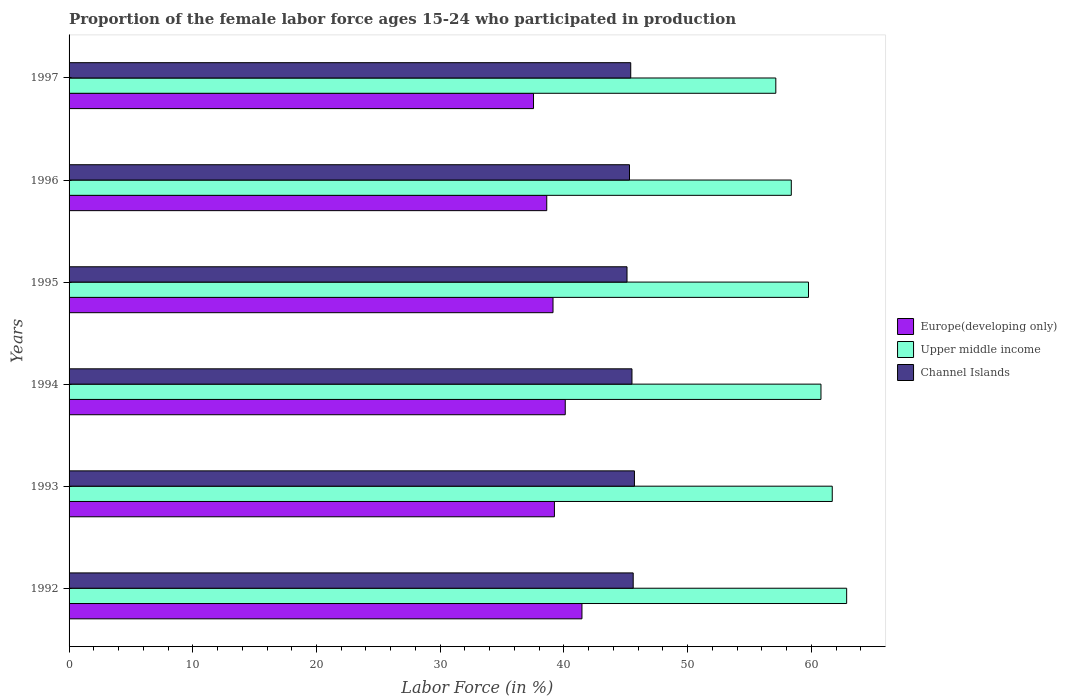How many different coloured bars are there?
Your response must be concise. 3. How many groups of bars are there?
Ensure brevity in your answer.  6. Are the number of bars per tick equal to the number of legend labels?
Offer a terse response. Yes. How many bars are there on the 2nd tick from the top?
Offer a terse response. 3. How many bars are there on the 6th tick from the bottom?
Your answer should be compact. 3. What is the proportion of the female labor force who participated in production in Europe(developing only) in 1997?
Give a very brief answer. 37.54. Across all years, what is the maximum proportion of the female labor force who participated in production in Upper middle income?
Your response must be concise. 62.85. Across all years, what is the minimum proportion of the female labor force who participated in production in Channel Islands?
Keep it short and to the point. 45.1. In which year was the proportion of the female labor force who participated in production in Upper middle income minimum?
Provide a succinct answer. 1997. What is the total proportion of the female labor force who participated in production in Europe(developing only) in the graph?
Make the answer very short. 236.07. What is the difference between the proportion of the female labor force who participated in production in Channel Islands in 1995 and that in 1997?
Your response must be concise. -0.3. What is the difference between the proportion of the female labor force who participated in production in Upper middle income in 1997 and the proportion of the female labor force who participated in production in Channel Islands in 1995?
Give a very brief answer. 12.03. What is the average proportion of the female labor force who participated in production in Europe(developing only) per year?
Your answer should be compact. 39.34. In the year 1994, what is the difference between the proportion of the female labor force who participated in production in Channel Islands and proportion of the female labor force who participated in production in Europe(developing only)?
Provide a short and direct response. 5.39. What is the ratio of the proportion of the female labor force who participated in production in Europe(developing only) in 1993 to that in 1997?
Provide a succinct answer. 1.05. Is the proportion of the female labor force who participated in production in Channel Islands in 1996 less than that in 1997?
Ensure brevity in your answer.  Yes. What is the difference between the highest and the second highest proportion of the female labor force who participated in production in Upper middle income?
Provide a short and direct response. 1.16. What is the difference between the highest and the lowest proportion of the female labor force who participated in production in Upper middle income?
Offer a terse response. 5.73. Is the sum of the proportion of the female labor force who participated in production in Upper middle income in 1993 and 1997 greater than the maximum proportion of the female labor force who participated in production in Europe(developing only) across all years?
Give a very brief answer. Yes. What does the 2nd bar from the top in 1997 represents?
Give a very brief answer. Upper middle income. What does the 1st bar from the bottom in 1995 represents?
Your answer should be compact. Europe(developing only). Is it the case that in every year, the sum of the proportion of the female labor force who participated in production in Upper middle income and proportion of the female labor force who participated in production in Channel Islands is greater than the proportion of the female labor force who participated in production in Europe(developing only)?
Offer a terse response. Yes. How many bars are there?
Give a very brief answer. 18. Are all the bars in the graph horizontal?
Keep it short and to the point. Yes. What is the difference between two consecutive major ticks on the X-axis?
Offer a terse response. 10. Does the graph contain any zero values?
Provide a short and direct response. No. How are the legend labels stacked?
Keep it short and to the point. Vertical. What is the title of the graph?
Give a very brief answer. Proportion of the female labor force ages 15-24 who participated in production. Does "Belize" appear as one of the legend labels in the graph?
Offer a very short reply. No. What is the label or title of the X-axis?
Offer a terse response. Labor Force (in %). What is the Labor Force (in %) in Europe(developing only) in 1992?
Provide a short and direct response. 41.46. What is the Labor Force (in %) of Upper middle income in 1992?
Offer a terse response. 62.85. What is the Labor Force (in %) of Channel Islands in 1992?
Offer a terse response. 45.6. What is the Labor Force (in %) of Europe(developing only) in 1993?
Keep it short and to the point. 39.23. What is the Labor Force (in %) of Upper middle income in 1993?
Provide a succinct answer. 61.69. What is the Labor Force (in %) of Channel Islands in 1993?
Keep it short and to the point. 45.7. What is the Labor Force (in %) of Europe(developing only) in 1994?
Provide a succinct answer. 40.11. What is the Labor Force (in %) of Upper middle income in 1994?
Your answer should be very brief. 60.78. What is the Labor Force (in %) in Channel Islands in 1994?
Your answer should be very brief. 45.5. What is the Labor Force (in %) of Europe(developing only) in 1995?
Offer a very short reply. 39.12. What is the Labor Force (in %) in Upper middle income in 1995?
Offer a very short reply. 59.77. What is the Labor Force (in %) of Channel Islands in 1995?
Keep it short and to the point. 45.1. What is the Labor Force (in %) of Europe(developing only) in 1996?
Offer a terse response. 38.61. What is the Labor Force (in %) of Upper middle income in 1996?
Offer a terse response. 58.38. What is the Labor Force (in %) in Channel Islands in 1996?
Your answer should be very brief. 45.3. What is the Labor Force (in %) of Europe(developing only) in 1997?
Provide a succinct answer. 37.54. What is the Labor Force (in %) of Upper middle income in 1997?
Make the answer very short. 57.13. What is the Labor Force (in %) in Channel Islands in 1997?
Ensure brevity in your answer.  45.4. Across all years, what is the maximum Labor Force (in %) of Europe(developing only)?
Your response must be concise. 41.46. Across all years, what is the maximum Labor Force (in %) in Upper middle income?
Offer a terse response. 62.85. Across all years, what is the maximum Labor Force (in %) in Channel Islands?
Offer a terse response. 45.7. Across all years, what is the minimum Labor Force (in %) in Europe(developing only)?
Offer a terse response. 37.54. Across all years, what is the minimum Labor Force (in %) in Upper middle income?
Make the answer very short. 57.13. Across all years, what is the minimum Labor Force (in %) of Channel Islands?
Provide a succinct answer. 45.1. What is the total Labor Force (in %) of Europe(developing only) in the graph?
Your answer should be very brief. 236.07. What is the total Labor Force (in %) of Upper middle income in the graph?
Your response must be concise. 360.6. What is the total Labor Force (in %) in Channel Islands in the graph?
Make the answer very short. 272.6. What is the difference between the Labor Force (in %) of Europe(developing only) in 1992 and that in 1993?
Ensure brevity in your answer.  2.23. What is the difference between the Labor Force (in %) in Upper middle income in 1992 and that in 1993?
Make the answer very short. 1.16. What is the difference between the Labor Force (in %) of Europe(developing only) in 1992 and that in 1994?
Offer a very short reply. 1.35. What is the difference between the Labor Force (in %) of Upper middle income in 1992 and that in 1994?
Give a very brief answer. 2.08. What is the difference between the Labor Force (in %) of Channel Islands in 1992 and that in 1994?
Your response must be concise. 0.1. What is the difference between the Labor Force (in %) in Europe(developing only) in 1992 and that in 1995?
Ensure brevity in your answer.  2.34. What is the difference between the Labor Force (in %) of Upper middle income in 1992 and that in 1995?
Your answer should be compact. 3.08. What is the difference between the Labor Force (in %) in Europe(developing only) in 1992 and that in 1996?
Keep it short and to the point. 2.85. What is the difference between the Labor Force (in %) of Upper middle income in 1992 and that in 1996?
Give a very brief answer. 4.47. What is the difference between the Labor Force (in %) in Europe(developing only) in 1992 and that in 1997?
Provide a short and direct response. 3.91. What is the difference between the Labor Force (in %) in Upper middle income in 1992 and that in 1997?
Provide a short and direct response. 5.73. What is the difference between the Labor Force (in %) of Channel Islands in 1992 and that in 1997?
Offer a terse response. 0.2. What is the difference between the Labor Force (in %) of Europe(developing only) in 1993 and that in 1994?
Offer a terse response. -0.87. What is the difference between the Labor Force (in %) of Upper middle income in 1993 and that in 1994?
Ensure brevity in your answer.  0.91. What is the difference between the Labor Force (in %) in Channel Islands in 1993 and that in 1994?
Provide a short and direct response. 0.2. What is the difference between the Labor Force (in %) of Europe(developing only) in 1993 and that in 1995?
Ensure brevity in your answer.  0.11. What is the difference between the Labor Force (in %) in Upper middle income in 1993 and that in 1995?
Provide a succinct answer. 1.92. What is the difference between the Labor Force (in %) of Europe(developing only) in 1993 and that in 1996?
Your response must be concise. 0.62. What is the difference between the Labor Force (in %) of Upper middle income in 1993 and that in 1996?
Provide a short and direct response. 3.31. What is the difference between the Labor Force (in %) in Europe(developing only) in 1993 and that in 1997?
Make the answer very short. 1.69. What is the difference between the Labor Force (in %) of Upper middle income in 1993 and that in 1997?
Provide a succinct answer. 4.56. What is the difference between the Labor Force (in %) of Channel Islands in 1993 and that in 1997?
Your response must be concise. 0.3. What is the difference between the Labor Force (in %) of Upper middle income in 1994 and that in 1995?
Your response must be concise. 1.01. What is the difference between the Labor Force (in %) of Channel Islands in 1994 and that in 1995?
Ensure brevity in your answer.  0.4. What is the difference between the Labor Force (in %) in Europe(developing only) in 1994 and that in 1996?
Offer a very short reply. 1.5. What is the difference between the Labor Force (in %) in Upper middle income in 1994 and that in 1996?
Your answer should be compact. 2.4. What is the difference between the Labor Force (in %) in Channel Islands in 1994 and that in 1996?
Keep it short and to the point. 0.2. What is the difference between the Labor Force (in %) in Europe(developing only) in 1994 and that in 1997?
Provide a succinct answer. 2.56. What is the difference between the Labor Force (in %) of Upper middle income in 1994 and that in 1997?
Offer a very short reply. 3.65. What is the difference between the Labor Force (in %) in Channel Islands in 1994 and that in 1997?
Your answer should be very brief. 0.1. What is the difference between the Labor Force (in %) of Europe(developing only) in 1995 and that in 1996?
Ensure brevity in your answer.  0.51. What is the difference between the Labor Force (in %) of Upper middle income in 1995 and that in 1996?
Keep it short and to the point. 1.39. What is the difference between the Labor Force (in %) in Europe(developing only) in 1995 and that in 1997?
Ensure brevity in your answer.  1.58. What is the difference between the Labor Force (in %) of Upper middle income in 1995 and that in 1997?
Provide a short and direct response. 2.64. What is the difference between the Labor Force (in %) of Europe(developing only) in 1996 and that in 1997?
Provide a short and direct response. 1.07. What is the difference between the Labor Force (in %) in Upper middle income in 1996 and that in 1997?
Your answer should be very brief. 1.25. What is the difference between the Labor Force (in %) of Europe(developing only) in 1992 and the Labor Force (in %) of Upper middle income in 1993?
Give a very brief answer. -20.23. What is the difference between the Labor Force (in %) of Europe(developing only) in 1992 and the Labor Force (in %) of Channel Islands in 1993?
Provide a succinct answer. -4.24. What is the difference between the Labor Force (in %) in Upper middle income in 1992 and the Labor Force (in %) in Channel Islands in 1993?
Give a very brief answer. 17.15. What is the difference between the Labor Force (in %) of Europe(developing only) in 1992 and the Labor Force (in %) of Upper middle income in 1994?
Provide a short and direct response. -19.32. What is the difference between the Labor Force (in %) of Europe(developing only) in 1992 and the Labor Force (in %) of Channel Islands in 1994?
Your response must be concise. -4.04. What is the difference between the Labor Force (in %) in Upper middle income in 1992 and the Labor Force (in %) in Channel Islands in 1994?
Make the answer very short. 17.35. What is the difference between the Labor Force (in %) of Europe(developing only) in 1992 and the Labor Force (in %) of Upper middle income in 1995?
Provide a short and direct response. -18.31. What is the difference between the Labor Force (in %) of Europe(developing only) in 1992 and the Labor Force (in %) of Channel Islands in 1995?
Offer a terse response. -3.64. What is the difference between the Labor Force (in %) of Upper middle income in 1992 and the Labor Force (in %) of Channel Islands in 1995?
Your response must be concise. 17.75. What is the difference between the Labor Force (in %) in Europe(developing only) in 1992 and the Labor Force (in %) in Upper middle income in 1996?
Make the answer very short. -16.92. What is the difference between the Labor Force (in %) of Europe(developing only) in 1992 and the Labor Force (in %) of Channel Islands in 1996?
Give a very brief answer. -3.84. What is the difference between the Labor Force (in %) in Upper middle income in 1992 and the Labor Force (in %) in Channel Islands in 1996?
Offer a very short reply. 17.55. What is the difference between the Labor Force (in %) of Europe(developing only) in 1992 and the Labor Force (in %) of Upper middle income in 1997?
Provide a short and direct response. -15.67. What is the difference between the Labor Force (in %) in Europe(developing only) in 1992 and the Labor Force (in %) in Channel Islands in 1997?
Your answer should be compact. -3.94. What is the difference between the Labor Force (in %) of Upper middle income in 1992 and the Labor Force (in %) of Channel Islands in 1997?
Offer a very short reply. 17.45. What is the difference between the Labor Force (in %) in Europe(developing only) in 1993 and the Labor Force (in %) in Upper middle income in 1994?
Keep it short and to the point. -21.54. What is the difference between the Labor Force (in %) of Europe(developing only) in 1993 and the Labor Force (in %) of Channel Islands in 1994?
Provide a short and direct response. -6.27. What is the difference between the Labor Force (in %) in Upper middle income in 1993 and the Labor Force (in %) in Channel Islands in 1994?
Provide a succinct answer. 16.19. What is the difference between the Labor Force (in %) in Europe(developing only) in 1993 and the Labor Force (in %) in Upper middle income in 1995?
Provide a short and direct response. -20.54. What is the difference between the Labor Force (in %) in Europe(developing only) in 1993 and the Labor Force (in %) in Channel Islands in 1995?
Provide a short and direct response. -5.87. What is the difference between the Labor Force (in %) of Upper middle income in 1993 and the Labor Force (in %) of Channel Islands in 1995?
Keep it short and to the point. 16.59. What is the difference between the Labor Force (in %) in Europe(developing only) in 1993 and the Labor Force (in %) in Upper middle income in 1996?
Your response must be concise. -19.15. What is the difference between the Labor Force (in %) of Europe(developing only) in 1993 and the Labor Force (in %) of Channel Islands in 1996?
Offer a very short reply. -6.07. What is the difference between the Labor Force (in %) in Upper middle income in 1993 and the Labor Force (in %) in Channel Islands in 1996?
Your answer should be compact. 16.39. What is the difference between the Labor Force (in %) in Europe(developing only) in 1993 and the Labor Force (in %) in Upper middle income in 1997?
Provide a short and direct response. -17.9. What is the difference between the Labor Force (in %) of Europe(developing only) in 1993 and the Labor Force (in %) of Channel Islands in 1997?
Make the answer very short. -6.17. What is the difference between the Labor Force (in %) of Upper middle income in 1993 and the Labor Force (in %) of Channel Islands in 1997?
Make the answer very short. 16.29. What is the difference between the Labor Force (in %) in Europe(developing only) in 1994 and the Labor Force (in %) in Upper middle income in 1995?
Ensure brevity in your answer.  -19.66. What is the difference between the Labor Force (in %) in Europe(developing only) in 1994 and the Labor Force (in %) in Channel Islands in 1995?
Provide a short and direct response. -4.99. What is the difference between the Labor Force (in %) of Upper middle income in 1994 and the Labor Force (in %) of Channel Islands in 1995?
Offer a very short reply. 15.68. What is the difference between the Labor Force (in %) of Europe(developing only) in 1994 and the Labor Force (in %) of Upper middle income in 1996?
Ensure brevity in your answer.  -18.27. What is the difference between the Labor Force (in %) in Europe(developing only) in 1994 and the Labor Force (in %) in Channel Islands in 1996?
Your answer should be compact. -5.19. What is the difference between the Labor Force (in %) in Upper middle income in 1994 and the Labor Force (in %) in Channel Islands in 1996?
Ensure brevity in your answer.  15.48. What is the difference between the Labor Force (in %) of Europe(developing only) in 1994 and the Labor Force (in %) of Upper middle income in 1997?
Your response must be concise. -17.02. What is the difference between the Labor Force (in %) of Europe(developing only) in 1994 and the Labor Force (in %) of Channel Islands in 1997?
Provide a succinct answer. -5.29. What is the difference between the Labor Force (in %) in Upper middle income in 1994 and the Labor Force (in %) in Channel Islands in 1997?
Provide a succinct answer. 15.38. What is the difference between the Labor Force (in %) in Europe(developing only) in 1995 and the Labor Force (in %) in Upper middle income in 1996?
Ensure brevity in your answer.  -19.26. What is the difference between the Labor Force (in %) in Europe(developing only) in 1995 and the Labor Force (in %) in Channel Islands in 1996?
Your response must be concise. -6.18. What is the difference between the Labor Force (in %) of Upper middle income in 1995 and the Labor Force (in %) of Channel Islands in 1996?
Offer a terse response. 14.47. What is the difference between the Labor Force (in %) in Europe(developing only) in 1995 and the Labor Force (in %) in Upper middle income in 1997?
Your answer should be very brief. -18.01. What is the difference between the Labor Force (in %) in Europe(developing only) in 1995 and the Labor Force (in %) in Channel Islands in 1997?
Offer a very short reply. -6.28. What is the difference between the Labor Force (in %) in Upper middle income in 1995 and the Labor Force (in %) in Channel Islands in 1997?
Offer a terse response. 14.37. What is the difference between the Labor Force (in %) of Europe(developing only) in 1996 and the Labor Force (in %) of Upper middle income in 1997?
Offer a terse response. -18.52. What is the difference between the Labor Force (in %) of Europe(developing only) in 1996 and the Labor Force (in %) of Channel Islands in 1997?
Give a very brief answer. -6.79. What is the difference between the Labor Force (in %) in Upper middle income in 1996 and the Labor Force (in %) in Channel Islands in 1997?
Provide a succinct answer. 12.98. What is the average Labor Force (in %) in Europe(developing only) per year?
Provide a succinct answer. 39.34. What is the average Labor Force (in %) of Upper middle income per year?
Your answer should be compact. 60.1. What is the average Labor Force (in %) in Channel Islands per year?
Make the answer very short. 45.43. In the year 1992, what is the difference between the Labor Force (in %) in Europe(developing only) and Labor Force (in %) in Upper middle income?
Your answer should be very brief. -21.4. In the year 1992, what is the difference between the Labor Force (in %) in Europe(developing only) and Labor Force (in %) in Channel Islands?
Provide a succinct answer. -4.14. In the year 1992, what is the difference between the Labor Force (in %) of Upper middle income and Labor Force (in %) of Channel Islands?
Make the answer very short. 17.25. In the year 1993, what is the difference between the Labor Force (in %) in Europe(developing only) and Labor Force (in %) in Upper middle income?
Give a very brief answer. -22.46. In the year 1993, what is the difference between the Labor Force (in %) of Europe(developing only) and Labor Force (in %) of Channel Islands?
Provide a succinct answer. -6.47. In the year 1993, what is the difference between the Labor Force (in %) in Upper middle income and Labor Force (in %) in Channel Islands?
Your response must be concise. 15.99. In the year 1994, what is the difference between the Labor Force (in %) of Europe(developing only) and Labor Force (in %) of Upper middle income?
Ensure brevity in your answer.  -20.67. In the year 1994, what is the difference between the Labor Force (in %) of Europe(developing only) and Labor Force (in %) of Channel Islands?
Keep it short and to the point. -5.39. In the year 1994, what is the difference between the Labor Force (in %) of Upper middle income and Labor Force (in %) of Channel Islands?
Your answer should be compact. 15.28. In the year 1995, what is the difference between the Labor Force (in %) in Europe(developing only) and Labor Force (in %) in Upper middle income?
Give a very brief answer. -20.65. In the year 1995, what is the difference between the Labor Force (in %) in Europe(developing only) and Labor Force (in %) in Channel Islands?
Your answer should be very brief. -5.98. In the year 1995, what is the difference between the Labor Force (in %) in Upper middle income and Labor Force (in %) in Channel Islands?
Keep it short and to the point. 14.67. In the year 1996, what is the difference between the Labor Force (in %) in Europe(developing only) and Labor Force (in %) in Upper middle income?
Keep it short and to the point. -19.77. In the year 1996, what is the difference between the Labor Force (in %) of Europe(developing only) and Labor Force (in %) of Channel Islands?
Your answer should be compact. -6.69. In the year 1996, what is the difference between the Labor Force (in %) of Upper middle income and Labor Force (in %) of Channel Islands?
Give a very brief answer. 13.08. In the year 1997, what is the difference between the Labor Force (in %) of Europe(developing only) and Labor Force (in %) of Upper middle income?
Ensure brevity in your answer.  -19.58. In the year 1997, what is the difference between the Labor Force (in %) of Europe(developing only) and Labor Force (in %) of Channel Islands?
Give a very brief answer. -7.86. In the year 1997, what is the difference between the Labor Force (in %) of Upper middle income and Labor Force (in %) of Channel Islands?
Offer a very short reply. 11.73. What is the ratio of the Labor Force (in %) in Europe(developing only) in 1992 to that in 1993?
Your answer should be compact. 1.06. What is the ratio of the Labor Force (in %) of Upper middle income in 1992 to that in 1993?
Give a very brief answer. 1.02. What is the ratio of the Labor Force (in %) in Channel Islands in 1992 to that in 1993?
Ensure brevity in your answer.  1. What is the ratio of the Labor Force (in %) in Europe(developing only) in 1992 to that in 1994?
Make the answer very short. 1.03. What is the ratio of the Labor Force (in %) of Upper middle income in 1992 to that in 1994?
Keep it short and to the point. 1.03. What is the ratio of the Labor Force (in %) in Channel Islands in 1992 to that in 1994?
Give a very brief answer. 1. What is the ratio of the Labor Force (in %) of Europe(developing only) in 1992 to that in 1995?
Make the answer very short. 1.06. What is the ratio of the Labor Force (in %) in Upper middle income in 1992 to that in 1995?
Keep it short and to the point. 1.05. What is the ratio of the Labor Force (in %) of Channel Islands in 1992 to that in 1995?
Your response must be concise. 1.01. What is the ratio of the Labor Force (in %) in Europe(developing only) in 1992 to that in 1996?
Provide a succinct answer. 1.07. What is the ratio of the Labor Force (in %) in Upper middle income in 1992 to that in 1996?
Make the answer very short. 1.08. What is the ratio of the Labor Force (in %) in Channel Islands in 1992 to that in 1996?
Ensure brevity in your answer.  1.01. What is the ratio of the Labor Force (in %) of Europe(developing only) in 1992 to that in 1997?
Provide a succinct answer. 1.1. What is the ratio of the Labor Force (in %) of Upper middle income in 1992 to that in 1997?
Provide a succinct answer. 1.1. What is the ratio of the Labor Force (in %) of Channel Islands in 1992 to that in 1997?
Your response must be concise. 1. What is the ratio of the Labor Force (in %) of Europe(developing only) in 1993 to that in 1994?
Your answer should be compact. 0.98. What is the ratio of the Labor Force (in %) of Europe(developing only) in 1993 to that in 1995?
Provide a succinct answer. 1. What is the ratio of the Labor Force (in %) in Upper middle income in 1993 to that in 1995?
Offer a terse response. 1.03. What is the ratio of the Labor Force (in %) in Channel Islands in 1993 to that in 1995?
Provide a short and direct response. 1.01. What is the ratio of the Labor Force (in %) of Europe(developing only) in 1993 to that in 1996?
Keep it short and to the point. 1.02. What is the ratio of the Labor Force (in %) of Upper middle income in 1993 to that in 1996?
Ensure brevity in your answer.  1.06. What is the ratio of the Labor Force (in %) in Channel Islands in 1993 to that in 1996?
Offer a terse response. 1.01. What is the ratio of the Labor Force (in %) in Europe(developing only) in 1993 to that in 1997?
Keep it short and to the point. 1.04. What is the ratio of the Labor Force (in %) of Upper middle income in 1993 to that in 1997?
Keep it short and to the point. 1.08. What is the ratio of the Labor Force (in %) in Channel Islands in 1993 to that in 1997?
Give a very brief answer. 1.01. What is the ratio of the Labor Force (in %) of Europe(developing only) in 1994 to that in 1995?
Provide a succinct answer. 1.03. What is the ratio of the Labor Force (in %) in Upper middle income in 1994 to that in 1995?
Offer a very short reply. 1.02. What is the ratio of the Labor Force (in %) in Channel Islands in 1994 to that in 1995?
Your answer should be compact. 1.01. What is the ratio of the Labor Force (in %) in Europe(developing only) in 1994 to that in 1996?
Ensure brevity in your answer.  1.04. What is the ratio of the Labor Force (in %) of Upper middle income in 1994 to that in 1996?
Your answer should be very brief. 1.04. What is the ratio of the Labor Force (in %) in Europe(developing only) in 1994 to that in 1997?
Give a very brief answer. 1.07. What is the ratio of the Labor Force (in %) in Upper middle income in 1994 to that in 1997?
Offer a terse response. 1.06. What is the ratio of the Labor Force (in %) of Europe(developing only) in 1995 to that in 1996?
Give a very brief answer. 1.01. What is the ratio of the Labor Force (in %) of Upper middle income in 1995 to that in 1996?
Make the answer very short. 1.02. What is the ratio of the Labor Force (in %) in Channel Islands in 1995 to that in 1996?
Your answer should be very brief. 1. What is the ratio of the Labor Force (in %) of Europe(developing only) in 1995 to that in 1997?
Your answer should be very brief. 1.04. What is the ratio of the Labor Force (in %) in Upper middle income in 1995 to that in 1997?
Give a very brief answer. 1.05. What is the ratio of the Labor Force (in %) in Channel Islands in 1995 to that in 1997?
Your answer should be compact. 0.99. What is the ratio of the Labor Force (in %) in Europe(developing only) in 1996 to that in 1997?
Make the answer very short. 1.03. What is the ratio of the Labor Force (in %) in Upper middle income in 1996 to that in 1997?
Your answer should be compact. 1.02. What is the difference between the highest and the second highest Labor Force (in %) of Europe(developing only)?
Offer a very short reply. 1.35. What is the difference between the highest and the second highest Labor Force (in %) in Upper middle income?
Give a very brief answer. 1.16. What is the difference between the highest and the second highest Labor Force (in %) in Channel Islands?
Make the answer very short. 0.1. What is the difference between the highest and the lowest Labor Force (in %) in Europe(developing only)?
Offer a terse response. 3.91. What is the difference between the highest and the lowest Labor Force (in %) of Upper middle income?
Provide a succinct answer. 5.73. What is the difference between the highest and the lowest Labor Force (in %) of Channel Islands?
Keep it short and to the point. 0.6. 